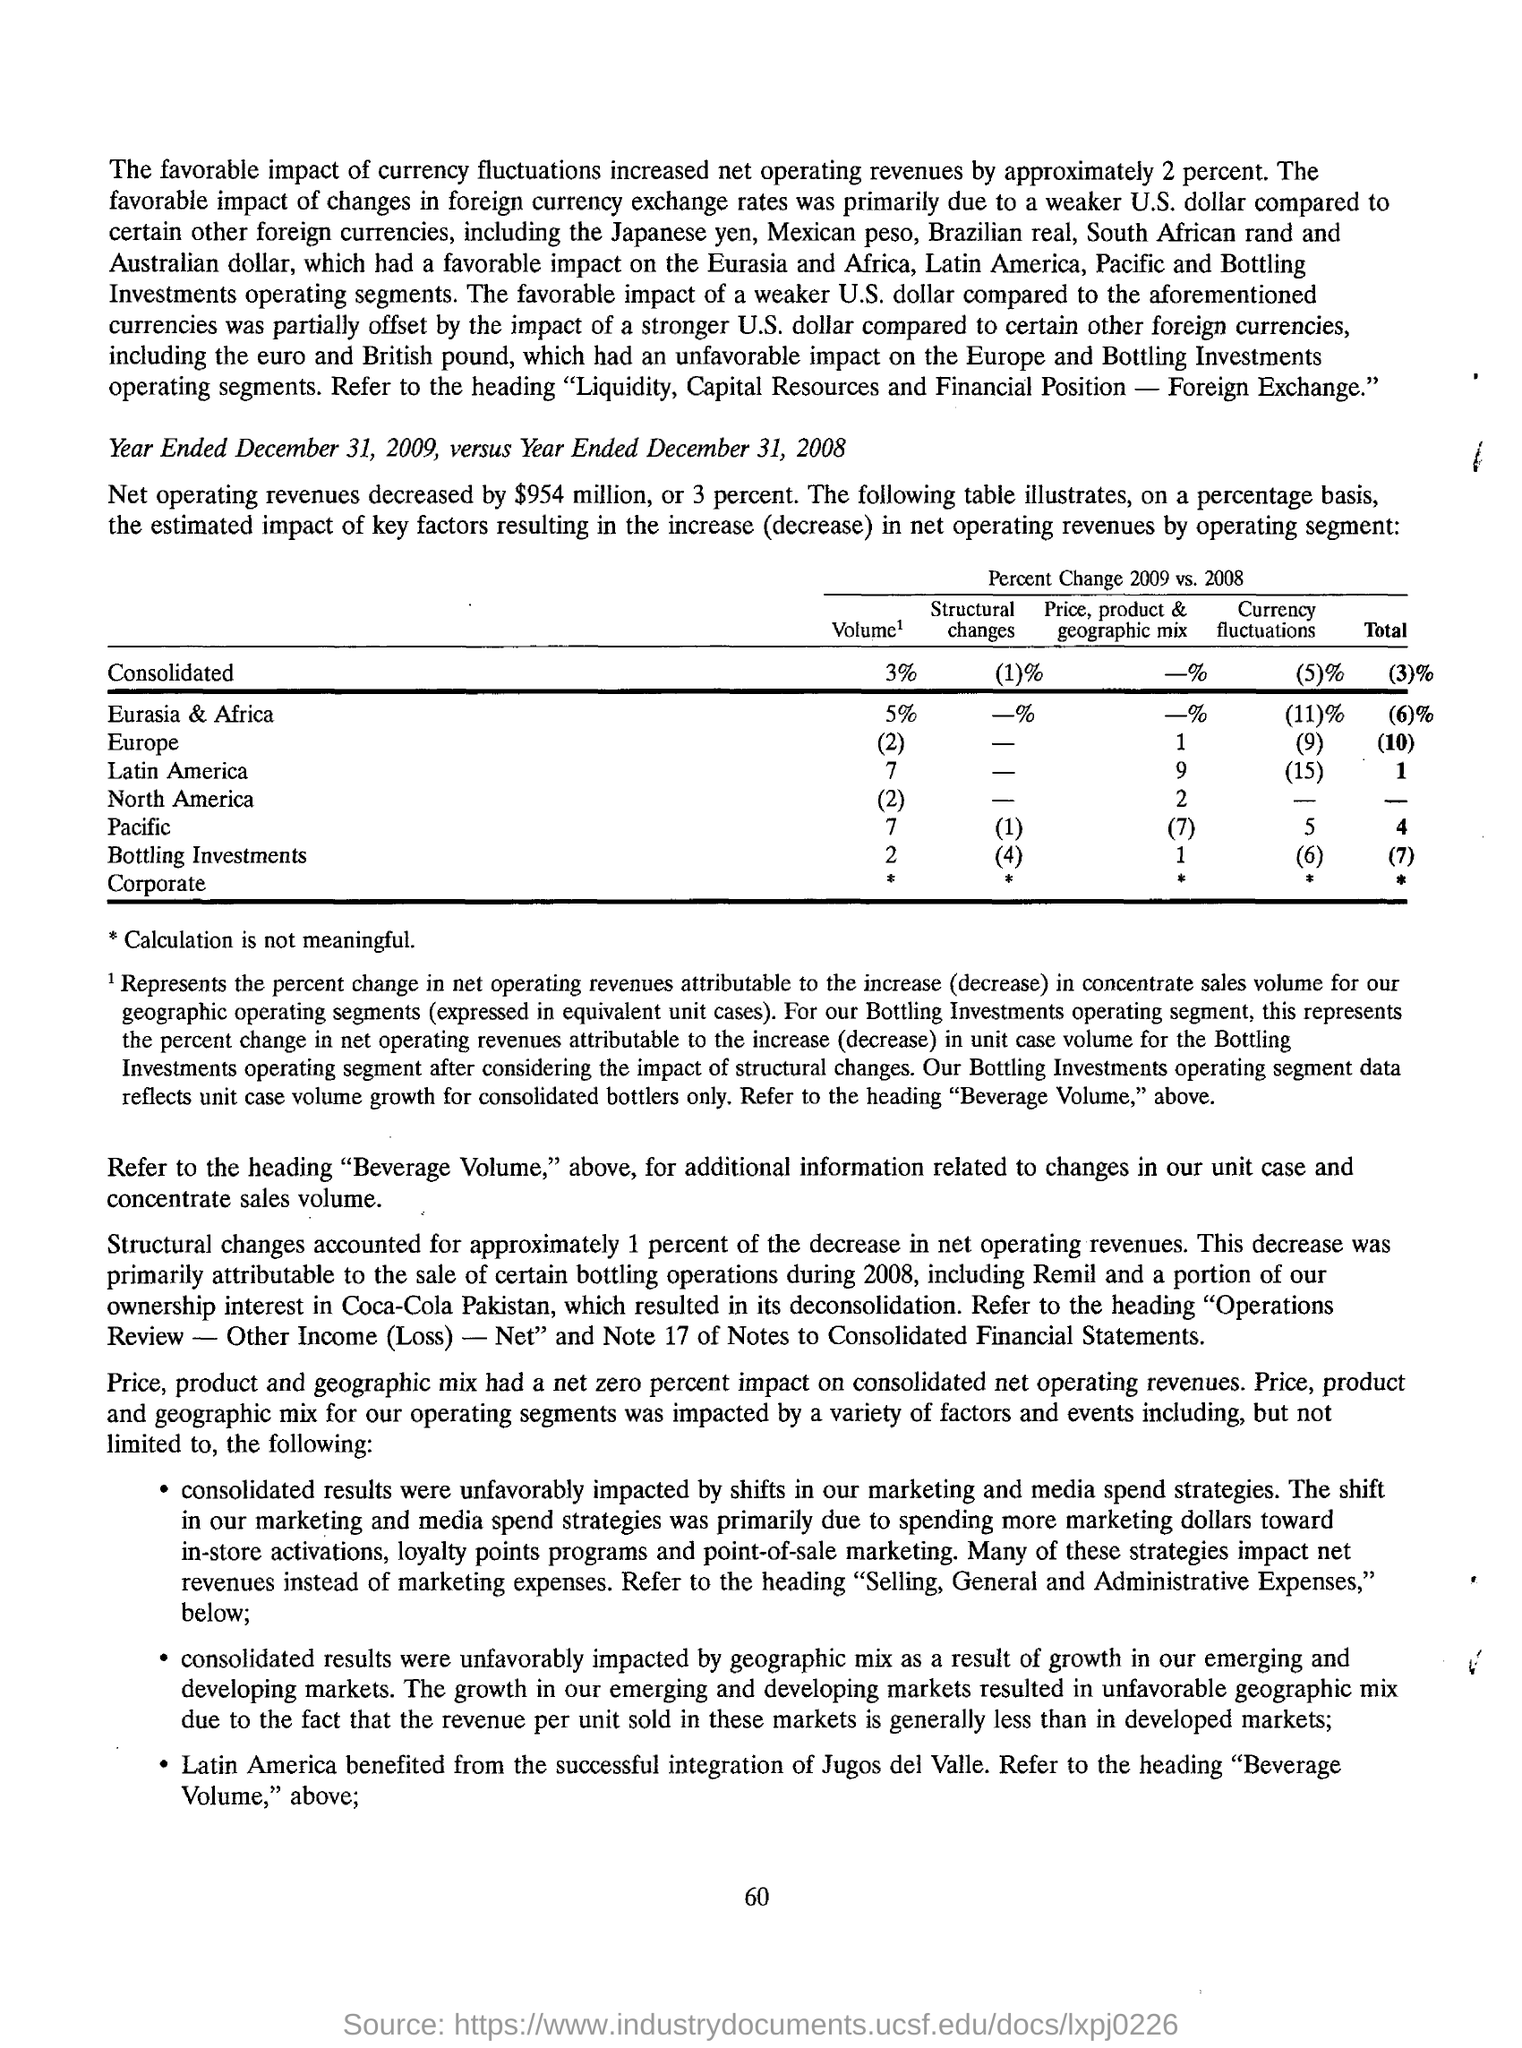List a handful of essential elements in this visual. The successful integration of Jugos de Valle has benefited Latin America. The favorable impact of currency fluctuations resulted in an approximate 2% increase in net operating revenues for the quarter. The net operating revenues of two different financial years, Year Ended December 31, 2009, and Year Ended December 31, 2008, are being compared. 